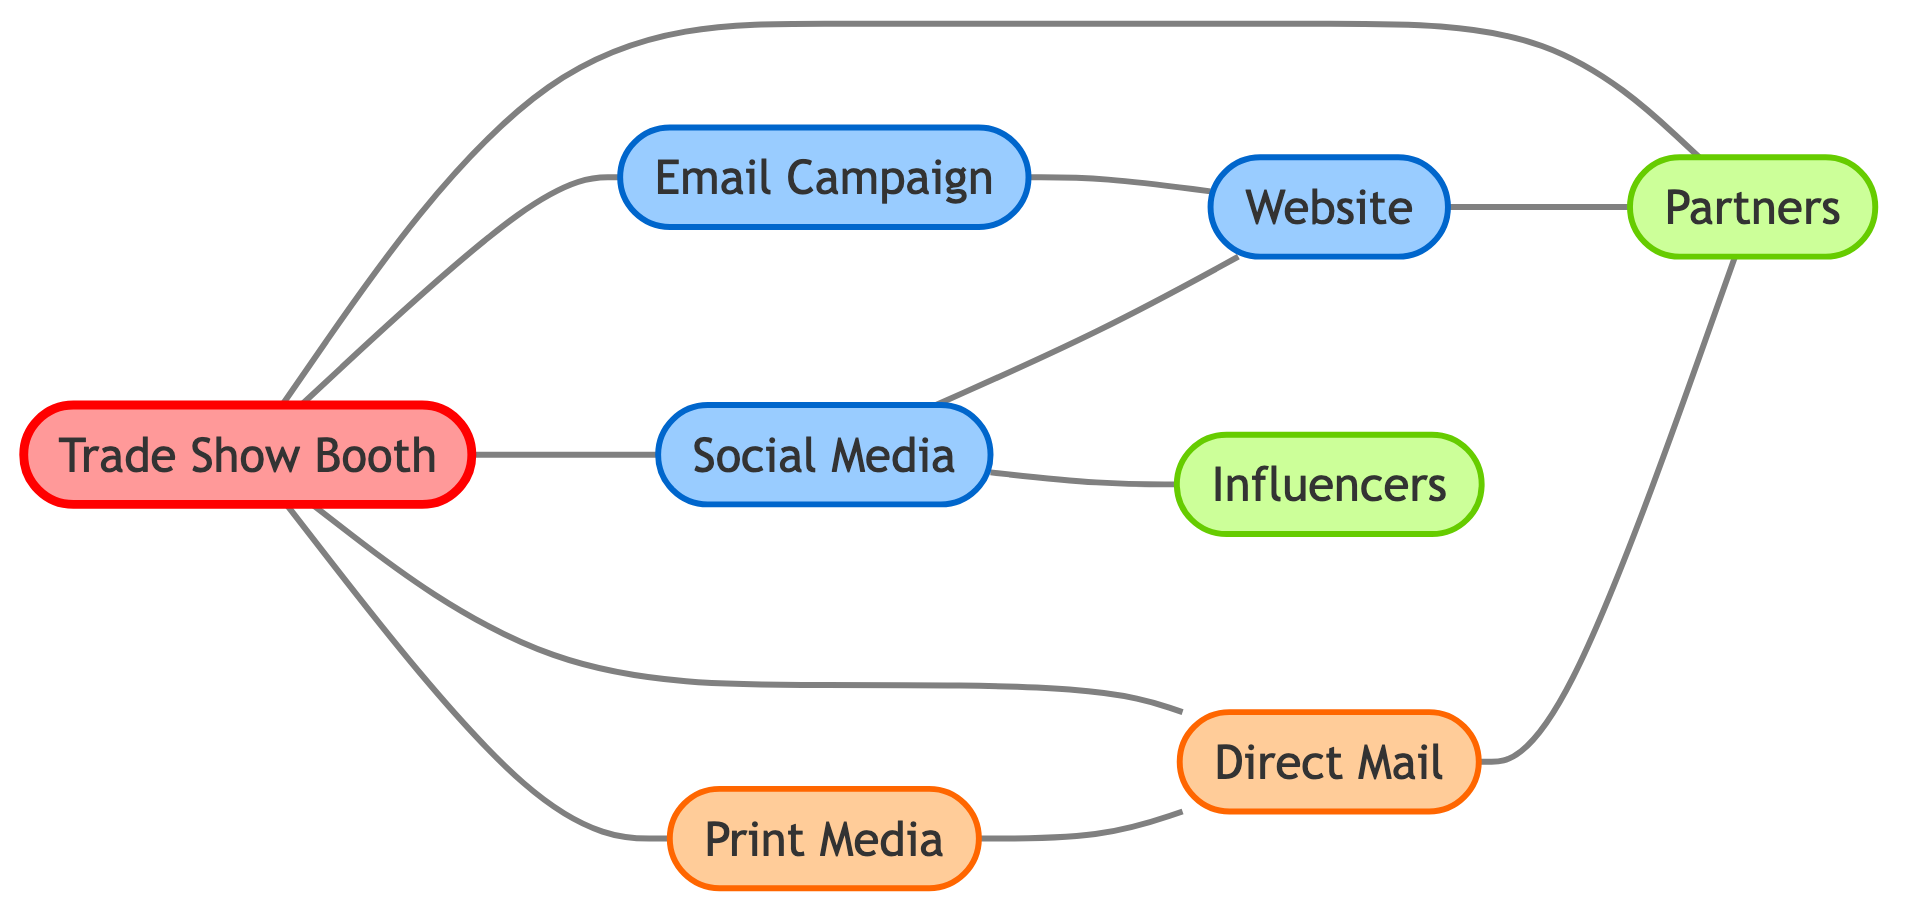What is the total number of nodes in the diagram? The nodes in the diagram represent different channels for promotional material distribution. They are: Trade Show Booth, Social Media, Email Campaign, Print Media, Direct Mail, Website, Partners, and Influencers. Counting these gives a total of 8 nodes.
Answer: 8 Which nodes are directly connected to the Trade Show Booth? The edges connected to the Trade Show Booth are: Social Media, Email Campaign, Print Media, Direct Mail, and Partners. This shows that there are 5 nodes that directly connect to the Trade Show Booth.
Answer: Social Media, Email Campaign, Print Media, Direct Mail, Partners How many edges are in the graph? To find the number of edges, we count the connections between the nodes. The edges listed are: Trade Show Booth - Social Media, Trade Show Booth - Email Campaign, Trade Show Booth - Print Media, Trade Show Booth - Direct Mail, Trade Show Booth - Partners, Email Campaign - Website, Print Media - Direct Mail, Social Media - Influencers, Social Media - Website, Website - Partners, Direct Mail - Partners. This results in a total of 11 edges.
Answer: 11 Which channel connects Direct Mail to Influencers? In the diagram, Direct Mail does not directly connect to Influencers; rather, both channels connect to Partners, but there is no direct edge between Direct Mail and Influencers. Thus, the answer is that no direct connection exists.
Answer: None What is the primary connection type between Social Media and Website? The connection between Social Media and the Website is represented by an edge, indicating a direct connection. This connection type is collaborative, implying that Social Media can drive traffic to the Website.
Answer: Direct connection Which promotional channel has connections to both Influencers and Partners? From the diagram, Social Media has a direct edge connecting it to Influencers and another edge connecting it to Partners. Thus, Social Media is the node that connects to both Influencers and Partners.
Answer: Social Media Identify the channel that connects Email Campaign to Partners through another node. The Email Campaign connects to the Website, which then has an edge leading to Partners. This sequence shows that the connection from Email Campaign to Partners goes through the Website.
Answer: Website How many channels are related to Print Media? The Print Media has edges connecting it to Direct Mail and Trade Show Booth. Counting these gives a total of 3 channels related to Print Media, including itself.
Answer: 3 